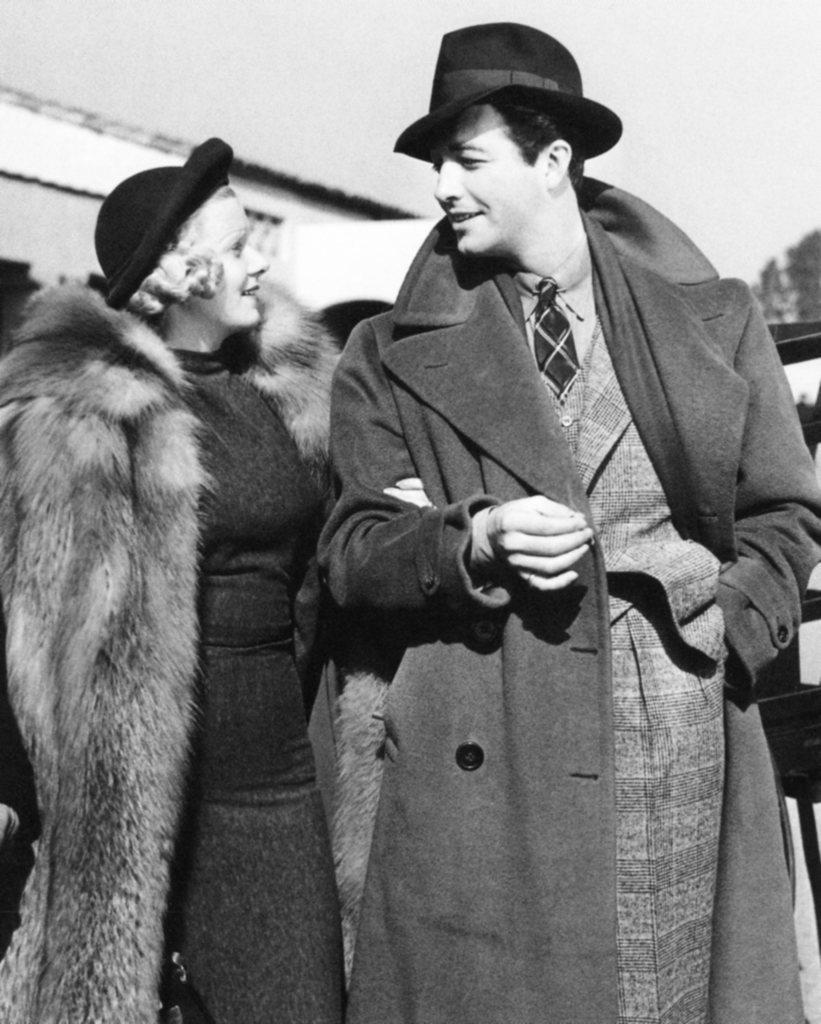Could you give a brief overview of what you see in this image? Here a man is standing he wore a coat, hat and smiling. In the left side a woman is standing and looking at this man. At the top it's a cloudy sky. 